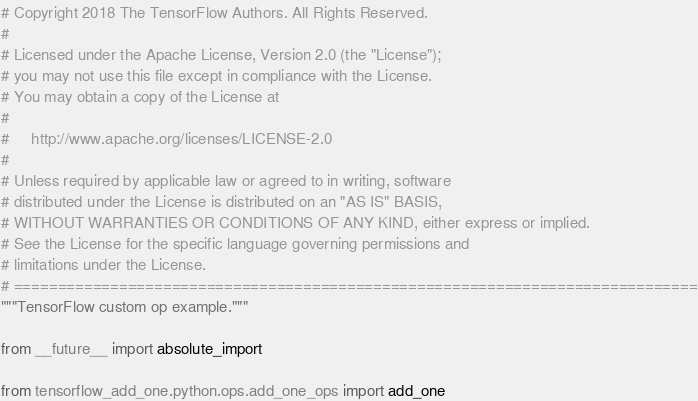<code> <loc_0><loc_0><loc_500><loc_500><_Python_># Copyright 2018 The TensorFlow Authors. All Rights Reserved.
#
# Licensed under the Apache License, Version 2.0 (the "License");
# you may not use this file except in compliance with the License.
# You may obtain a copy of the License at
#
#     http://www.apache.org/licenses/LICENSE-2.0
#
# Unless required by applicable law or agreed to in writing, software
# distributed under the License is distributed on an "AS IS" BASIS,
# WITHOUT WARRANTIES OR CONDITIONS OF ANY KIND, either express or implied.
# See the License for the specific language governing permissions and
# limitations under the License.
# ==============================================================================
"""TensorFlow custom op example."""

from __future__ import absolute_import

from tensorflow_add_one.python.ops.add_one_ops import add_one
</code> 